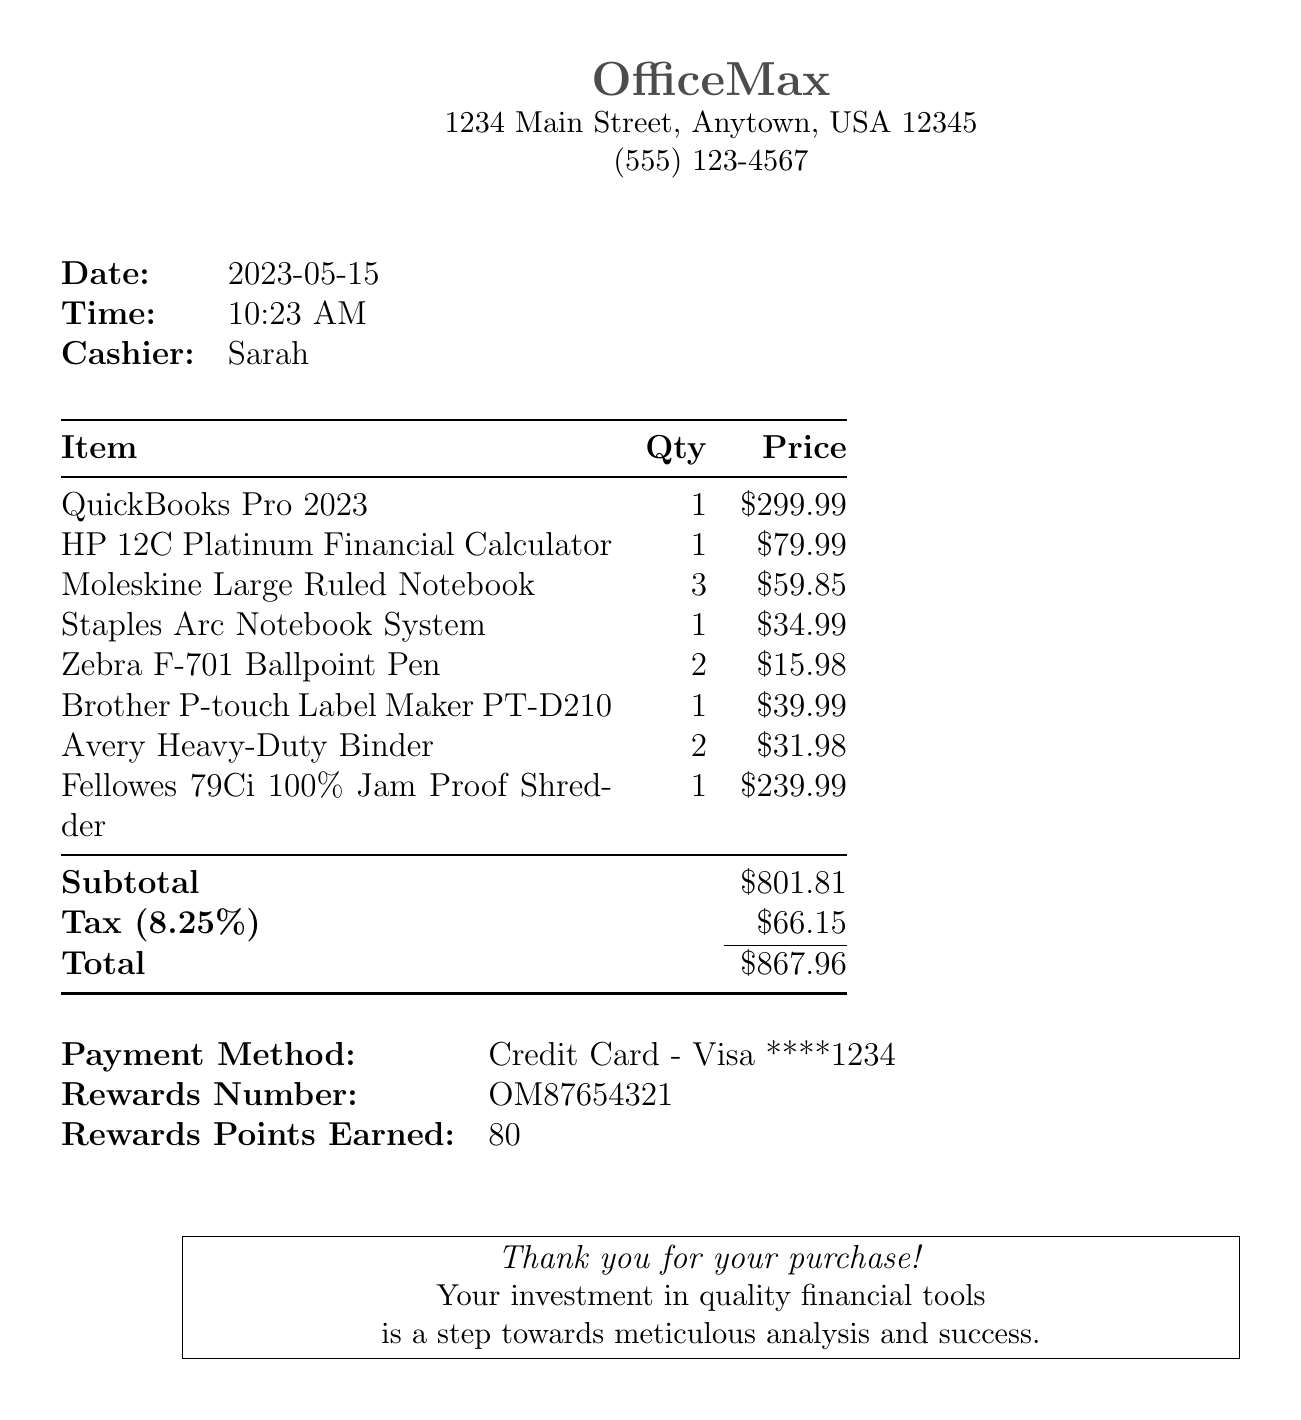what is the store name? The store name is located in the header of the receipt.
Answer: OfficeMax what is the total amount spent? The total amount is found at the bottom of the receipt.
Answer: $867.96 who was the cashier for this transaction? The cashier's name is listed in the receipt table.
Answer: Sarah what is the quantity of Moleskine Large Ruled Notebooks purchased? The quantity is specified next to the item's description on the receipt.
Answer: 3 what is the tax rate applied to the purchase? The tax rate is indicated preceding the calculated tax amount.
Answer: 8.25% how many rewards points were earned? The rewards points earned are stated near the payment method.
Answer: 80 what is the price of the HP 12C Platinum Financial Calculator? The price is listed next to the item's name in the receipt.
Answer: $79.99 what type of financial software was purchased? The software name is shown as part of the itemized list.
Answer: QuickBooks Pro 2023 what is the subtotal before tax? The subtotal is provided before the tax calculation in the receipt.
Answer: $801.81 